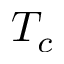<formula> <loc_0><loc_0><loc_500><loc_500>T _ { c }</formula> 